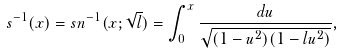<formula> <loc_0><loc_0><loc_500><loc_500>s ^ { - 1 } ( x ) = s n ^ { - 1 } ( x ; \sqrt { l } ) = \int _ { 0 } ^ { x } \frac { d u } { \sqrt { ( 1 - u ^ { 2 } ) ( 1 - l u ^ { 2 } ) } } ,</formula> 